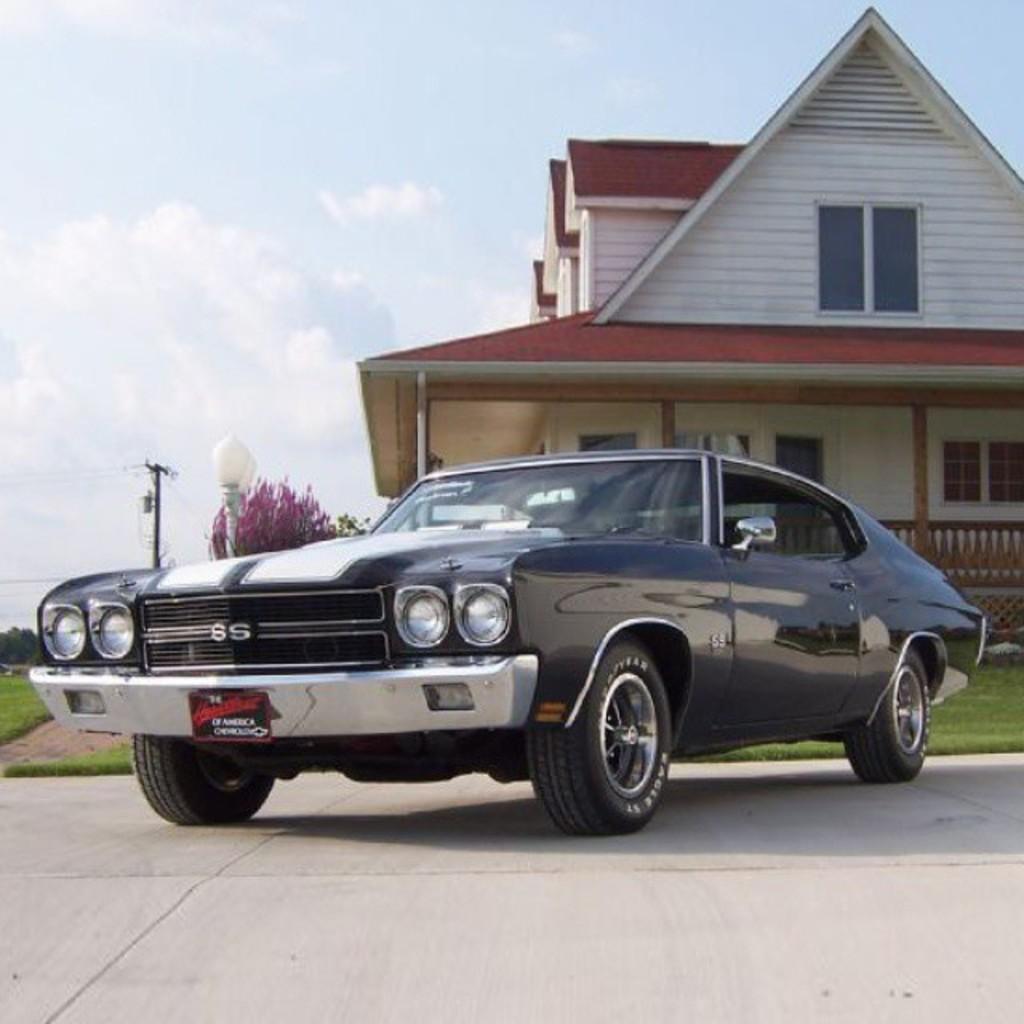In one or two sentences, can you explain what this image depicts? In this image I can see a car which is black in color on the ground. In the background I can see few trees, two poles, the building and the sky. 